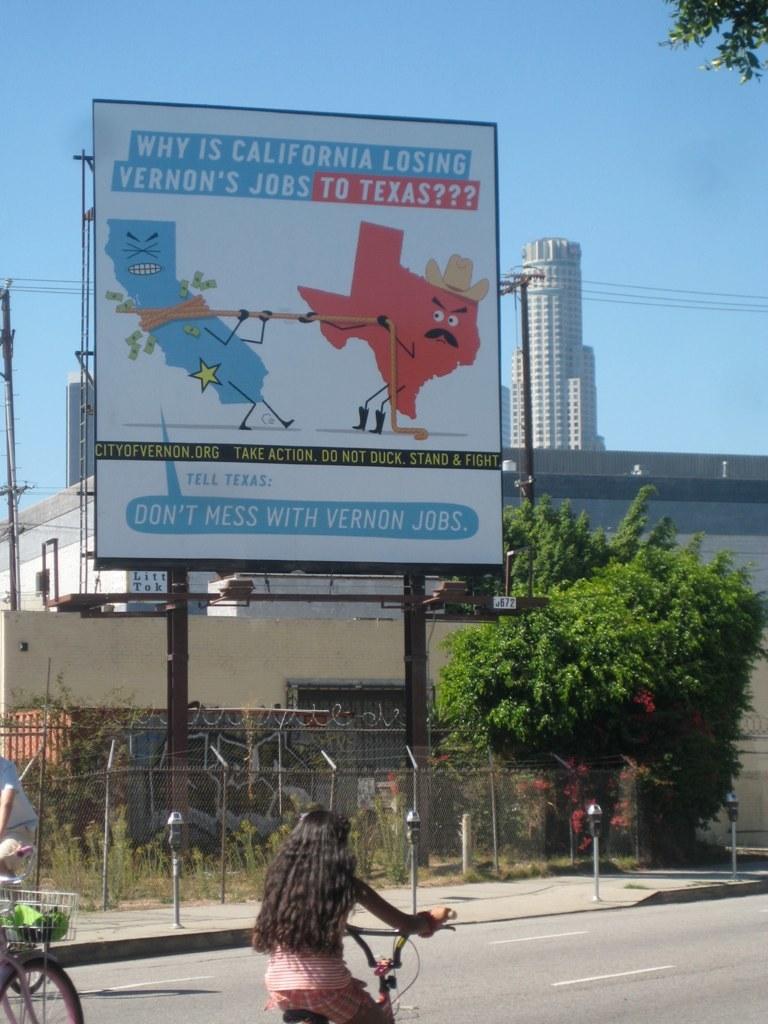Who is losing jobs to texas?
Your answer should be compact. California. 